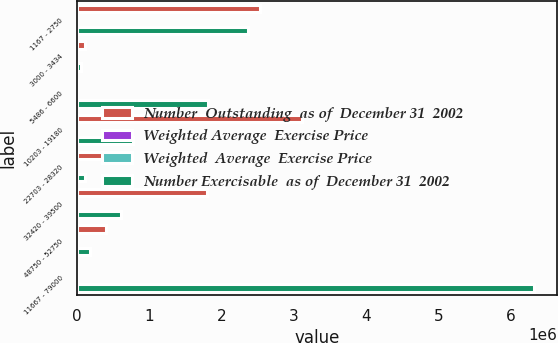Convert chart. <chart><loc_0><loc_0><loc_500><loc_500><stacked_bar_chart><ecel><fcel>1167 - 2750<fcel>3000 - 3434<fcel>5486 - 6600<fcel>10203 - 19180<fcel>22703 - 28320<fcel>32420 - 39500<fcel>48750 - 52750<fcel>11667 - 79000<nl><fcel>Number  Outstanding  as of  December 31  2002<fcel>2.53538e+06<fcel>103864<fcel>42.43<fcel>3.10938e+06<fcel>582200<fcel>1.7966e+06<fcel>397200<fcel>42.43<nl><fcel>Weighted Average  Exercise Price<fcel>3.74<fcel>4.8<fcel>6.08<fcel>6.28<fcel>7.96<fcel>6.31<fcel>7.12<fcel>5.98<nl><fcel>Weighted  Average  Exercise Price<fcel>2.21<fcel>3.02<fcel>6.01<fcel>14.36<fcel>25.12<fcel>35.49<fcel>49.37<fcel>13.97<nl><fcel>Number Exercisable  as of  December 31  2002<fcel>2.36096e+06<fcel>53928<fcel>1.8088e+06<fcel>774615<fcel>110000<fcel>606600<fcel>181600<fcel>6.32571e+06<nl></chart> 